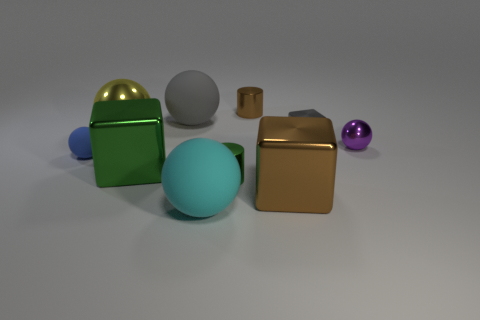There is a rubber object that is left of the big yellow sphere; is it the same color as the small metallic block?
Give a very brief answer. No. Are there fewer big brown metallic cubes that are to the right of the big gray matte object than big gray objects?
Provide a succinct answer. No. The tiny gray thing that is the same material as the tiny purple object is what shape?
Offer a terse response. Cube. Is the tiny blue object made of the same material as the purple thing?
Make the answer very short. No. Is the number of shiny blocks right of the small purple metal thing less than the number of green things behind the tiny brown cylinder?
Give a very brief answer. No. The sphere that is the same color as the small cube is what size?
Offer a terse response. Large. There is a block that is behind the tiny ball in front of the small purple shiny ball; how many yellow metal objects are right of it?
Provide a short and direct response. 0. Does the small rubber thing have the same color as the small metallic ball?
Your answer should be compact. No. Is there a tiny metal sphere of the same color as the big metallic sphere?
Ensure brevity in your answer.  No. There is a metallic sphere that is the same size as the blue rubber object; what color is it?
Provide a short and direct response. Purple. 